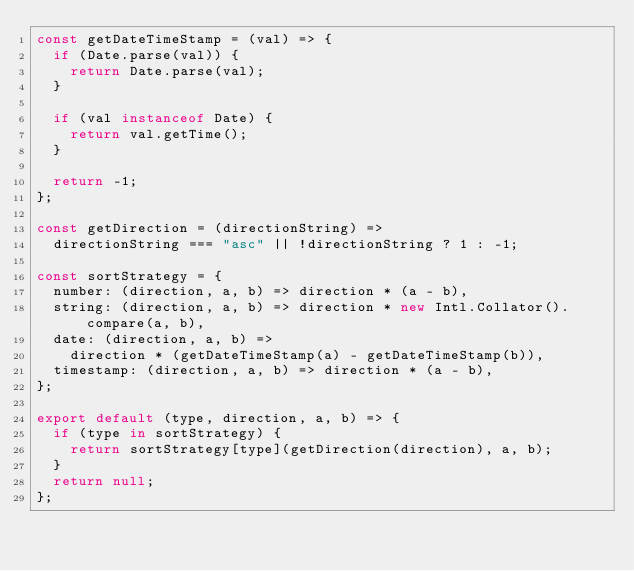Convert code to text. <code><loc_0><loc_0><loc_500><loc_500><_JavaScript_>const getDateTimeStamp = (val) => {
  if (Date.parse(val)) {
    return Date.parse(val);
  }

  if (val instanceof Date) {
    return val.getTime();
  }

  return -1;
};

const getDirection = (directionString) =>
  directionString === "asc" || !directionString ? 1 : -1;

const sortStrategy = {
  number: (direction, a, b) => direction * (a - b),
  string: (direction, a, b) => direction * new Intl.Collator().compare(a, b),
  date: (direction, a, b) =>
    direction * (getDateTimeStamp(a) - getDateTimeStamp(b)),
  timestamp: (direction, a, b) => direction * (a - b),
};

export default (type, direction, a, b) => {
  if (type in sortStrategy) {
    return sortStrategy[type](getDirection(direction), a, b);
  }
  return null;
};
</code> 